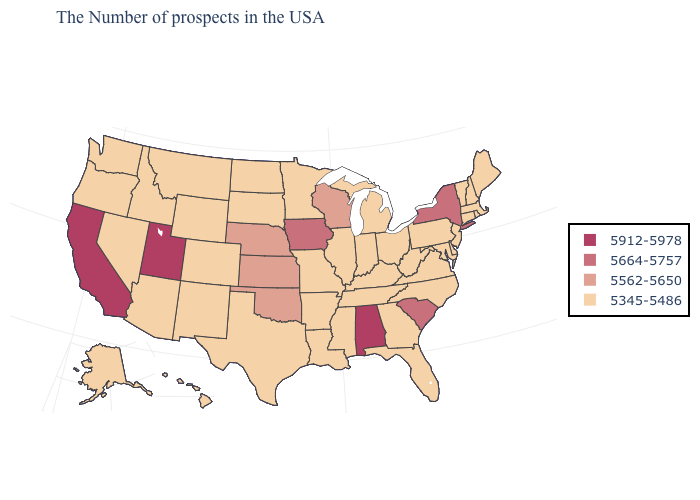What is the value of Tennessee?
Write a very short answer. 5345-5486. What is the value of Wisconsin?
Concise answer only. 5562-5650. Which states have the highest value in the USA?
Quick response, please. Alabama, Utah, California. Which states hav the highest value in the South?
Keep it brief. Alabama. Does Iowa have the highest value in the MidWest?
Short answer required. Yes. What is the value of Iowa?
Short answer required. 5664-5757. What is the highest value in the South ?
Answer briefly. 5912-5978. Does the first symbol in the legend represent the smallest category?
Concise answer only. No. Name the states that have a value in the range 5912-5978?
Answer briefly. Alabama, Utah, California. Which states have the lowest value in the South?
Short answer required. Delaware, Maryland, Virginia, North Carolina, West Virginia, Florida, Georgia, Kentucky, Tennessee, Mississippi, Louisiana, Arkansas, Texas. Does the map have missing data?
Give a very brief answer. No. What is the highest value in the MidWest ?
Give a very brief answer. 5664-5757. Among the states that border Nebraska , does Iowa have the highest value?
Short answer required. Yes. Does Minnesota have the highest value in the MidWest?
Keep it brief. No. What is the lowest value in the USA?
Answer briefly. 5345-5486. 